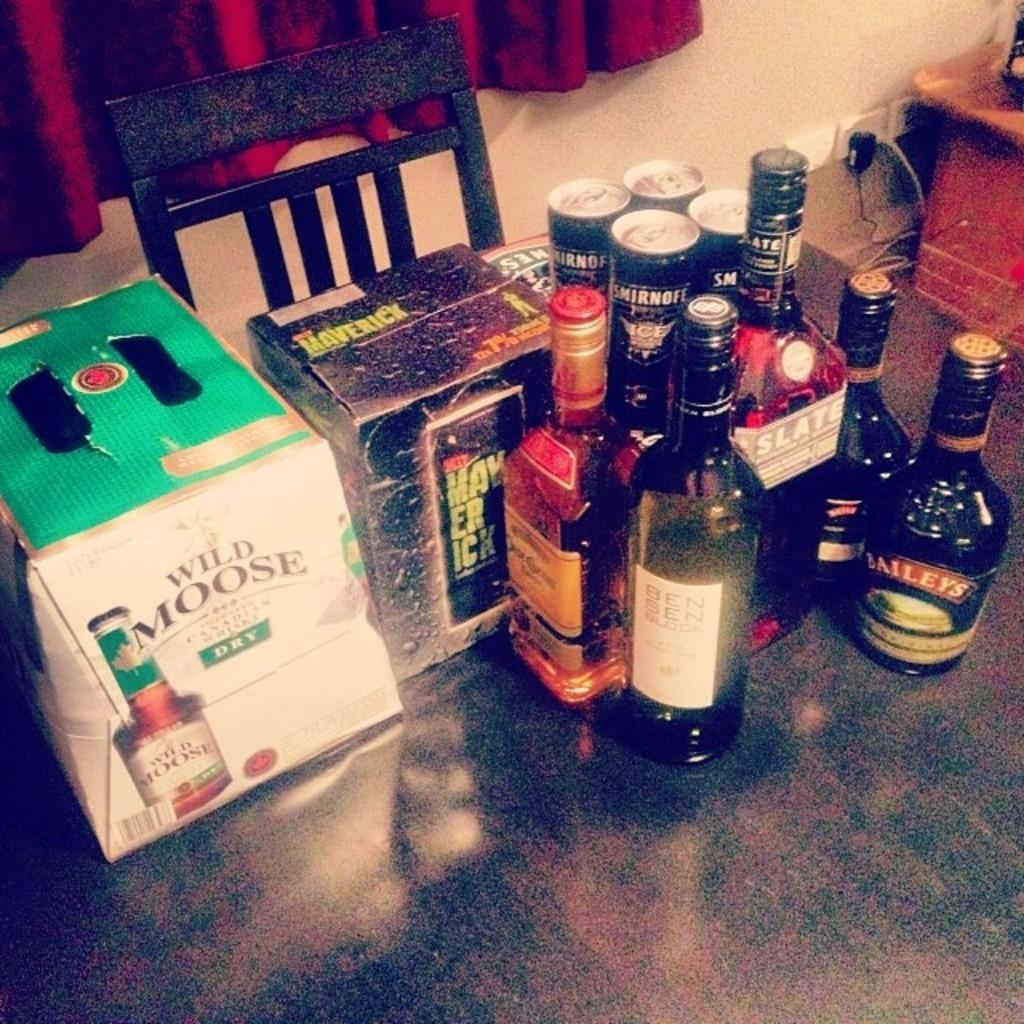<image>
Render a clear and concise summary of the photo. A case of Wild Moose Dry next to many other containers of alcohol. 